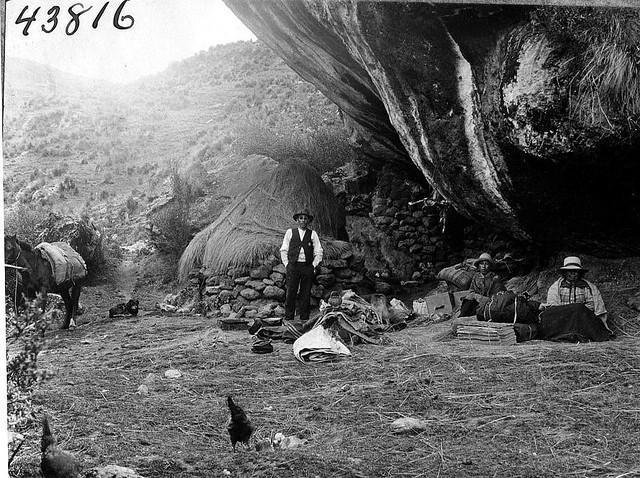How many people are in this picture?
Give a very brief answer. 3. How many chickens do you see in the picture?
Give a very brief answer. 2. How many people are visible?
Give a very brief answer. 2. 